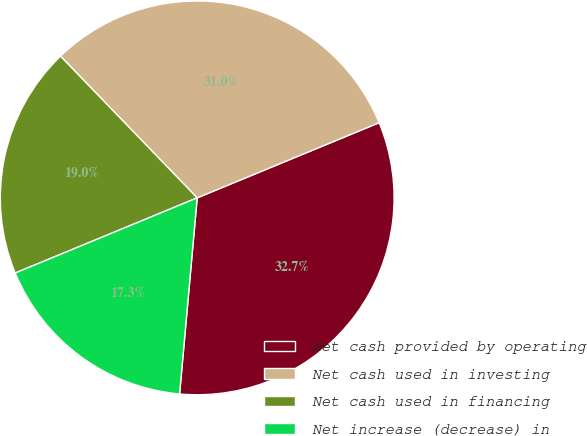Convert chart to OTSL. <chart><loc_0><loc_0><loc_500><loc_500><pie_chart><fcel>Net cash provided by operating<fcel>Net cash used in investing<fcel>Net cash used in financing<fcel>Net increase (decrease) in<nl><fcel>32.66%<fcel>30.98%<fcel>19.02%<fcel>17.34%<nl></chart> 